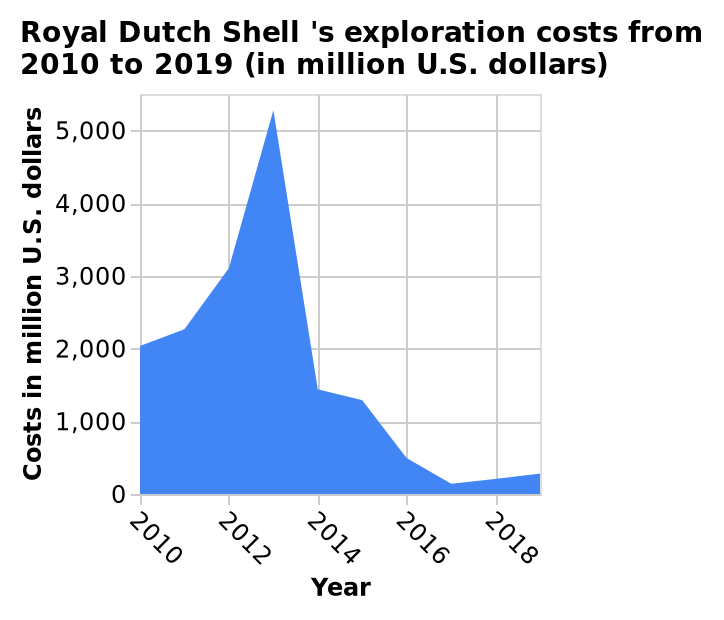<image>
What does the x-axis represent? The x-axis represents the years from 2010 to 2018 along a linear scale. What was the trend in exportation costs between 2010 and 2018?  The trend in exportation costs showed a decrease between 2016-2018, reaching their lowest point since 2010. 